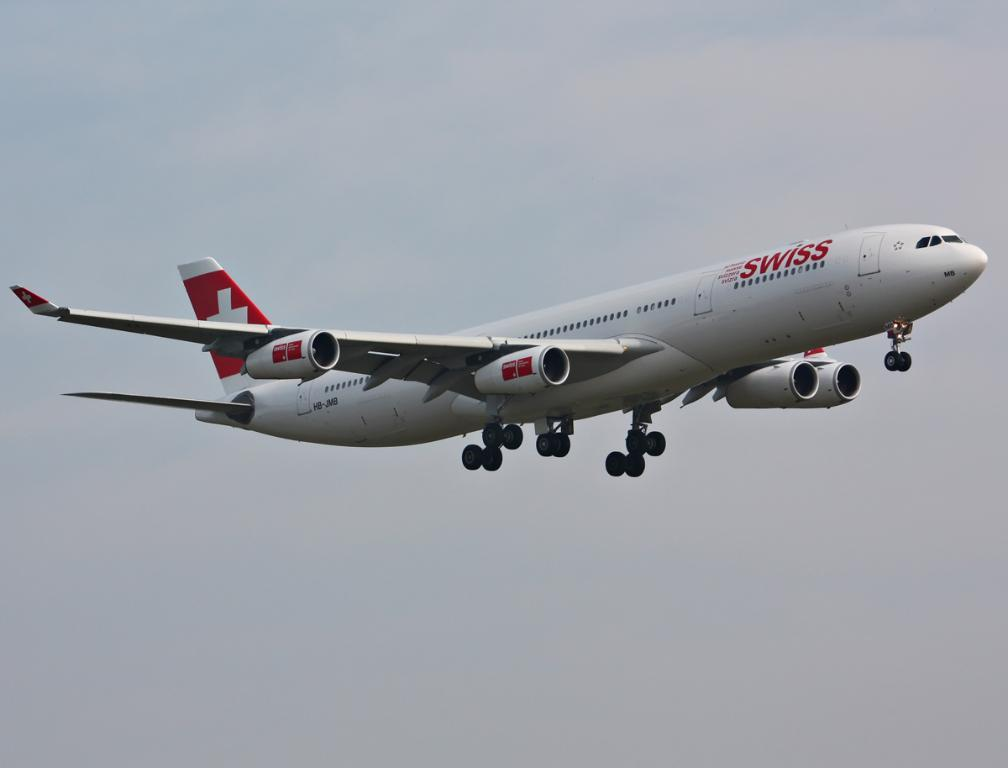What is the main subject of the image? The main subject of the image is an airplane. Can you describe the position of the airplane in the image? The airplane is in the air. What can be seen in the background of the image? There is sky visible in the background of the image. What type of spark can be seen coming from the airplane in the image? There is no spark visible in the image; the airplane is simply flying in the sky. 